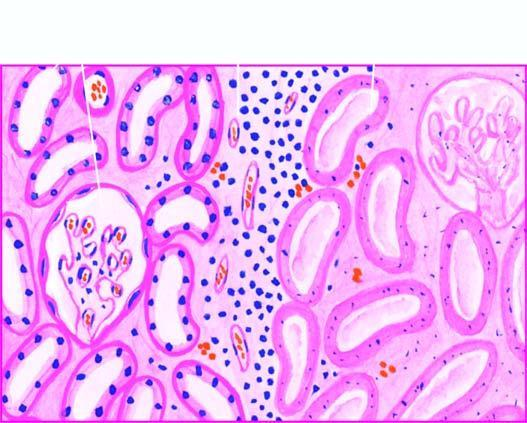does the affected area on right show cells with intensely eosinophilic cytoplasm of tubular cells?
Answer the question using a single word or phrase. Yes 